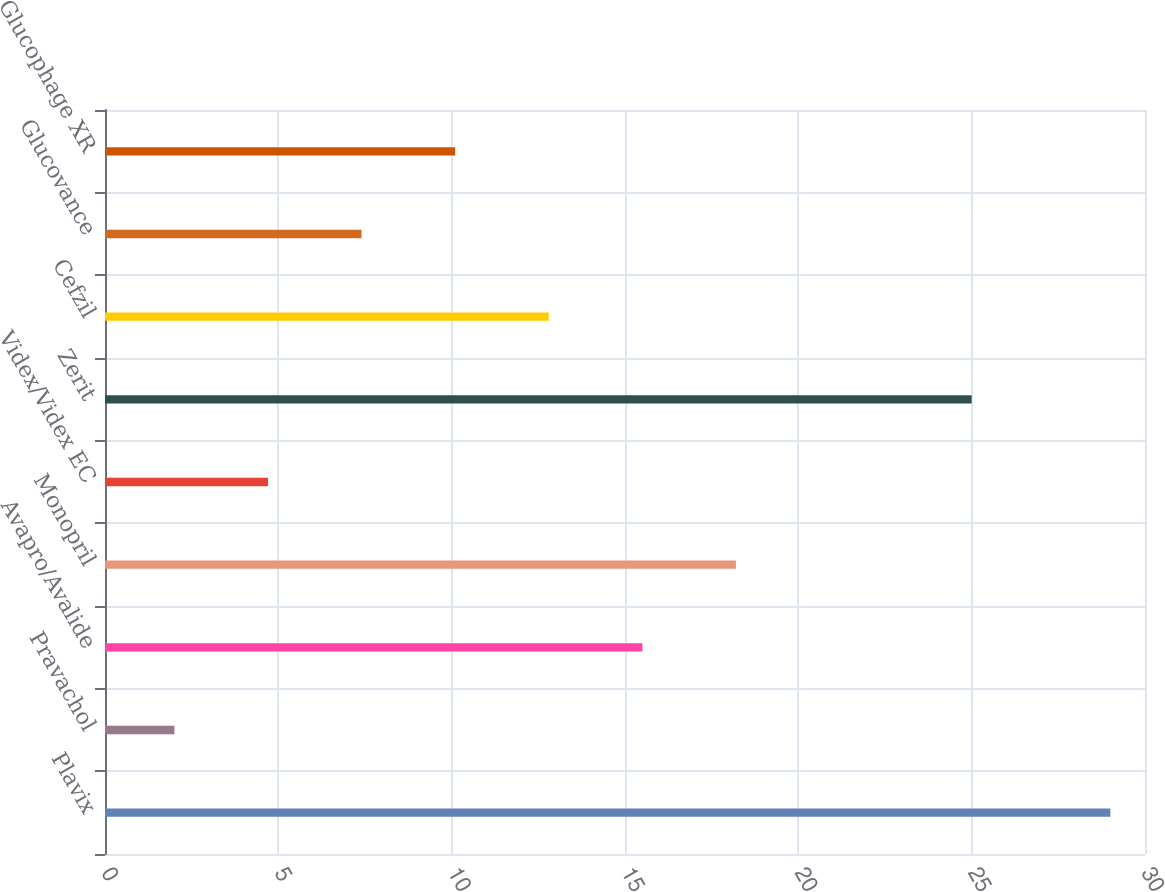Convert chart to OTSL. <chart><loc_0><loc_0><loc_500><loc_500><bar_chart><fcel>Plavix<fcel>Pravachol<fcel>Avapro/Avalide<fcel>Monopril<fcel>Videx/Videx EC<fcel>Zerit<fcel>Cefzil<fcel>Glucovance<fcel>Glucophage XR<nl><fcel>29<fcel>2<fcel>15.5<fcel>18.2<fcel>4.7<fcel>25<fcel>12.8<fcel>7.4<fcel>10.1<nl></chart> 